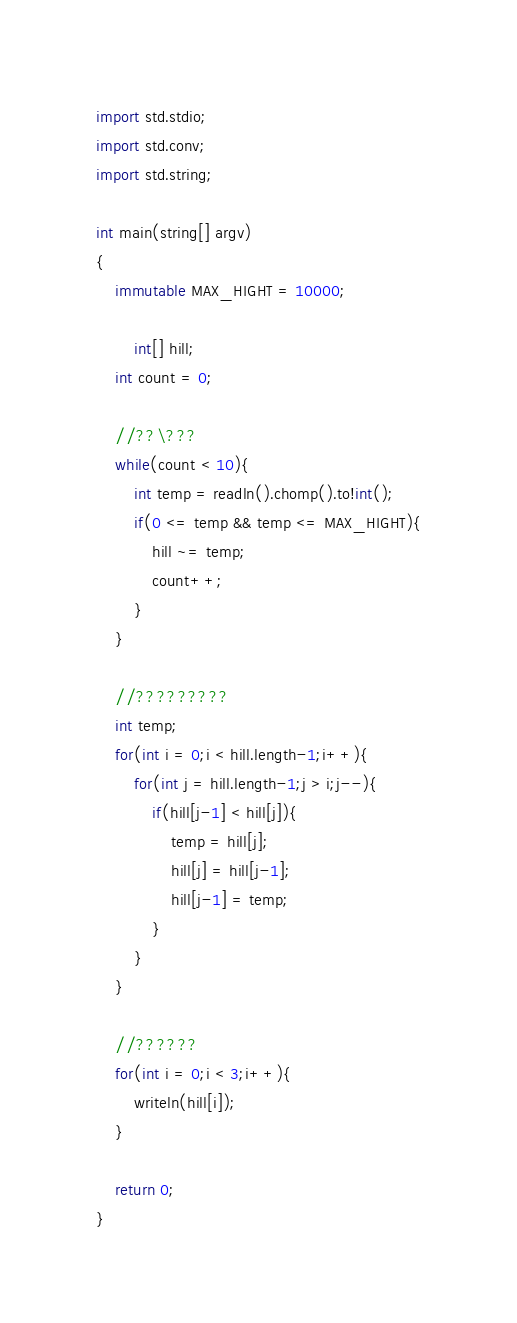<code> <loc_0><loc_0><loc_500><loc_500><_D_>import std.stdio;
import std.conv;
import std.string;

int main(string[] argv)
{
	immutable MAX_HIGHT = 10000;

        int[] hill;
	int count = 0;

	//??\???
	while(count < 10){
		int temp = readln().chomp().to!int();
		if(0 <= temp && temp <= MAX_HIGHT){
			hill ~= temp;
			count++;
		}
	}

	//?????????
	int temp;
	for(int i = 0;i < hill.length-1;i++){
		for(int j = hill.length-1;j > i;j--){
			if(hill[j-1] < hill[j]){
				temp = hill[j];
				hill[j] = hill[j-1];
				hill[j-1] = temp;
			}
		}
	}

	//??????
	for(int i = 0;i < 3;i++){
		writeln(hill[i]);
	}

    return 0;
}</code> 